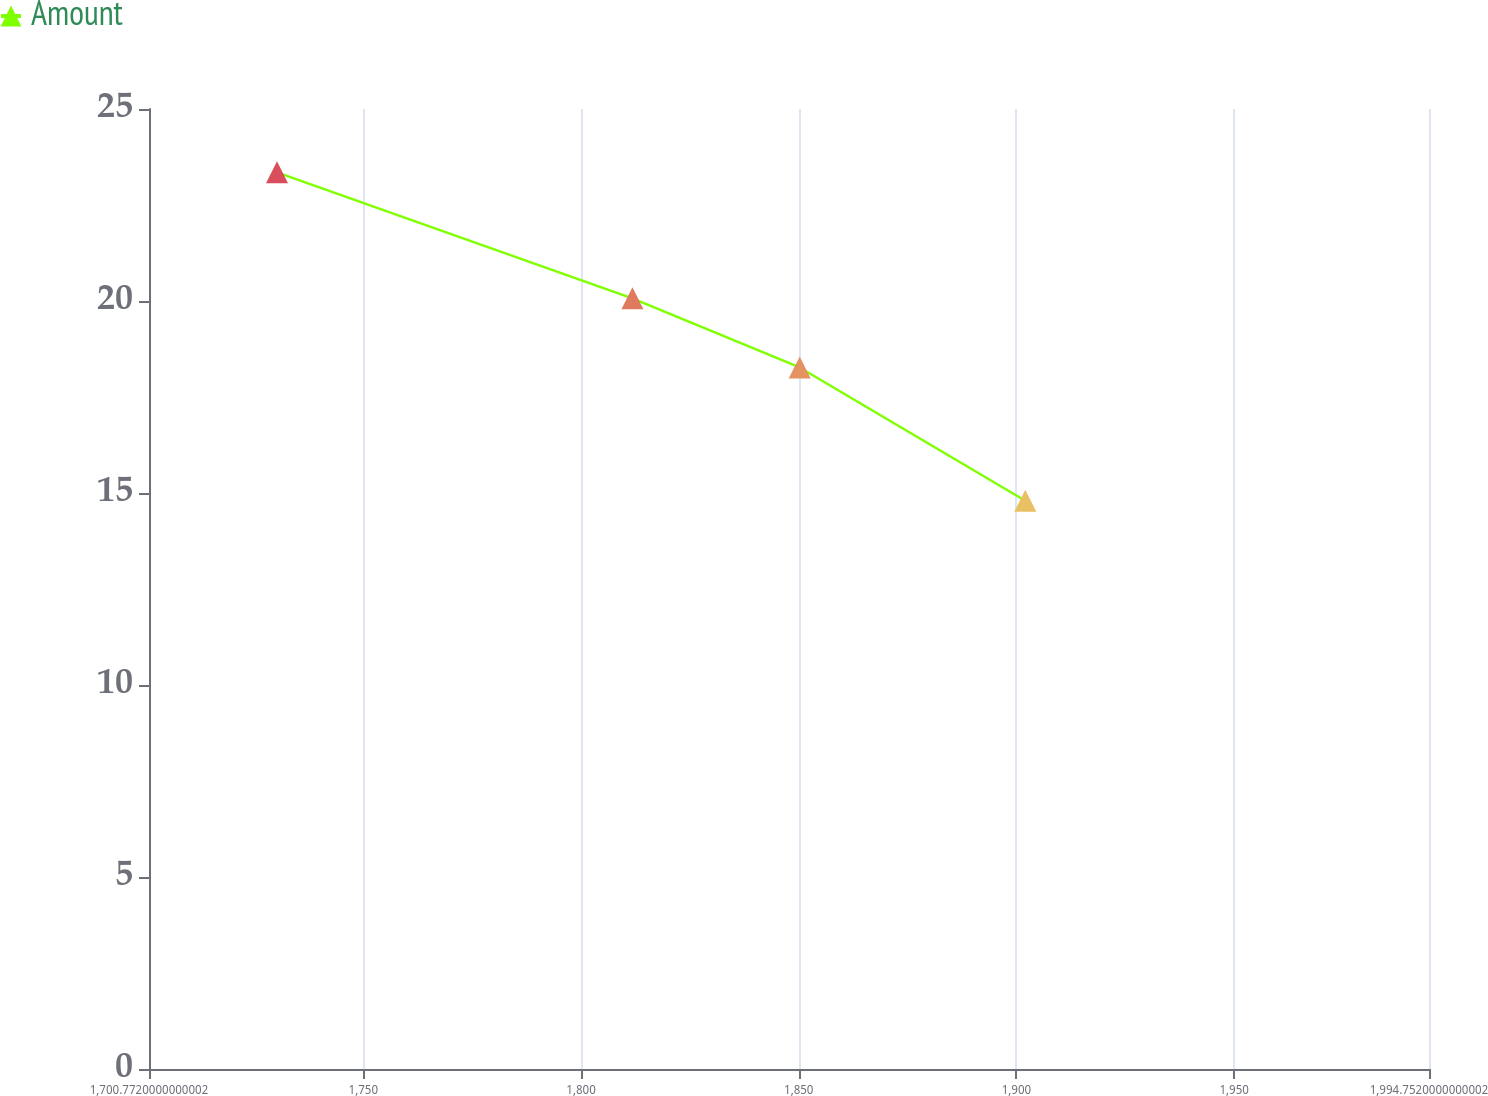Convert chart. <chart><loc_0><loc_0><loc_500><loc_500><line_chart><ecel><fcel>Amount<nl><fcel>1730.17<fcel>23.35<nl><fcel>1811.8<fcel>20.07<nl><fcel>1850.21<fcel>18.27<nl><fcel>1902.03<fcel>14.8<nl><fcel>2024.15<fcel>5.36<nl></chart> 